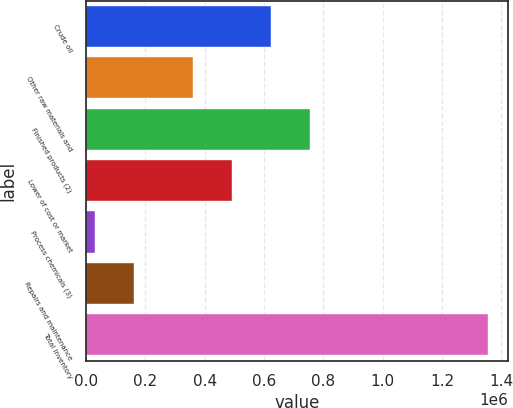<chart> <loc_0><loc_0><loc_500><loc_500><bar_chart><fcel>Crude oil<fcel>Other raw materials and<fcel>Finished products (2)<fcel>Lower of cost or market<fcel>Process chemicals (3)<fcel>Repairs and maintenance<fcel>Total inventory<nl><fcel>624717<fcel>360124<fcel>757014<fcel>492421<fcel>31413<fcel>163710<fcel>1.35438e+06<nl></chart> 